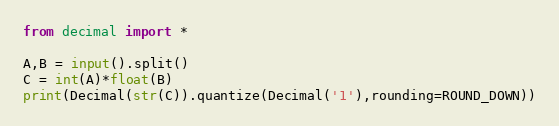<code> <loc_0><loc_0><loc_500><loc_500><_Python_>from decimal import *

A,B = input().split()
C = int(A)*float(B)
print(Decimal(str(C)).quantize(Decimal('1'),rounding=ROUND_DOWN))</code> 